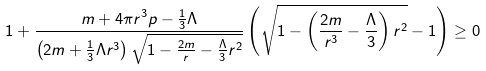<formula> <loc_0><loc_0><loc_500><loc_500>1 + \frac { m + 4 \pi r ^ { 3 } p - \frac { 1 } { 3 } \Lambda } { \left ( 2 m + \frac { 1 } { 3 } \Lambda r ^ { 3 } \right ) \sqrt { 1 - \frac { 2 m } { r } - \frac { \Lambda } { 3 } r ^ { 2 } } } \left ( \sqrt { 1 - \left ( \frac { 2 m } { r ^ { 3 } } - \frac { \Lambda } { 3 } \right ) r ^ { 2 } } - 1 \right ) \geq 0</formula> 